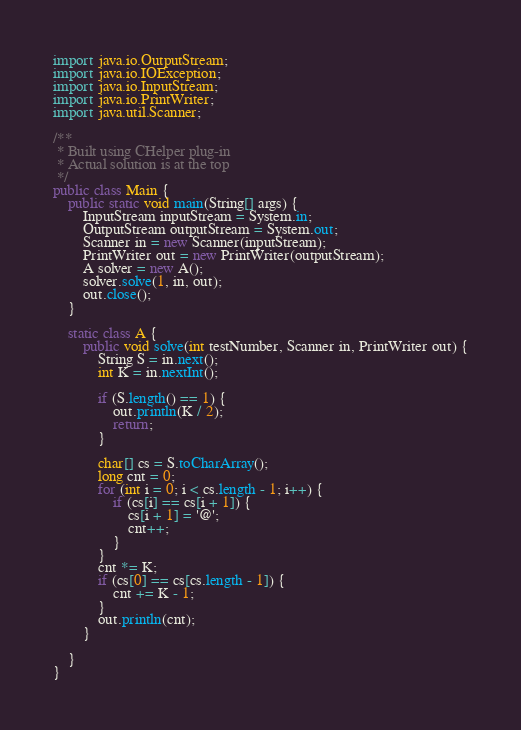Convert code to text. <code><loc_0><loc_0><loc_500><loc_500><_Java_>import java.io.OutputStream;
import java.io.IOException;
import java.io.InputStream;
import java.io.PrintWriter;
import java.util.Scanner;

/**
 * Built using CHelper plug-in
 * Actual solution is at the top
 */
public class Main {
    public static void main(String[] args) {
        InputStream inputStream = System.in;
        OutputStream outputStream = System.out;
        Scanner in = new Scanner(inputStream);
        PrintWriter out = new PrintWriter(outputStream);
        A solver = new A();
        solver.solve(1, in, out);
        out.close();
    }

    static class A {
        public void solve(int testNumber, Scanner in, PrintWriter out) {
            String S = in.next();
            int K = in.nextInt();

            if (S.length() == 1) {
                out.println(K / 2);
                return;
            }

            char[] cs = S.toCharArray();
            long cnt = 0;
            for (int i = 0; i < cs.length - 1; i++) {
                if (cs[i] == cs[i + 1]) {
                    cs[i + 1] = '@';
                    cnt++;
                }
            }
            cnt *= K;
            if (cs[0] == cs[cs.length - 1]) {
                cnt += K - 1;
            }
            out.println(cnt);
        }

    }
}

</code> 